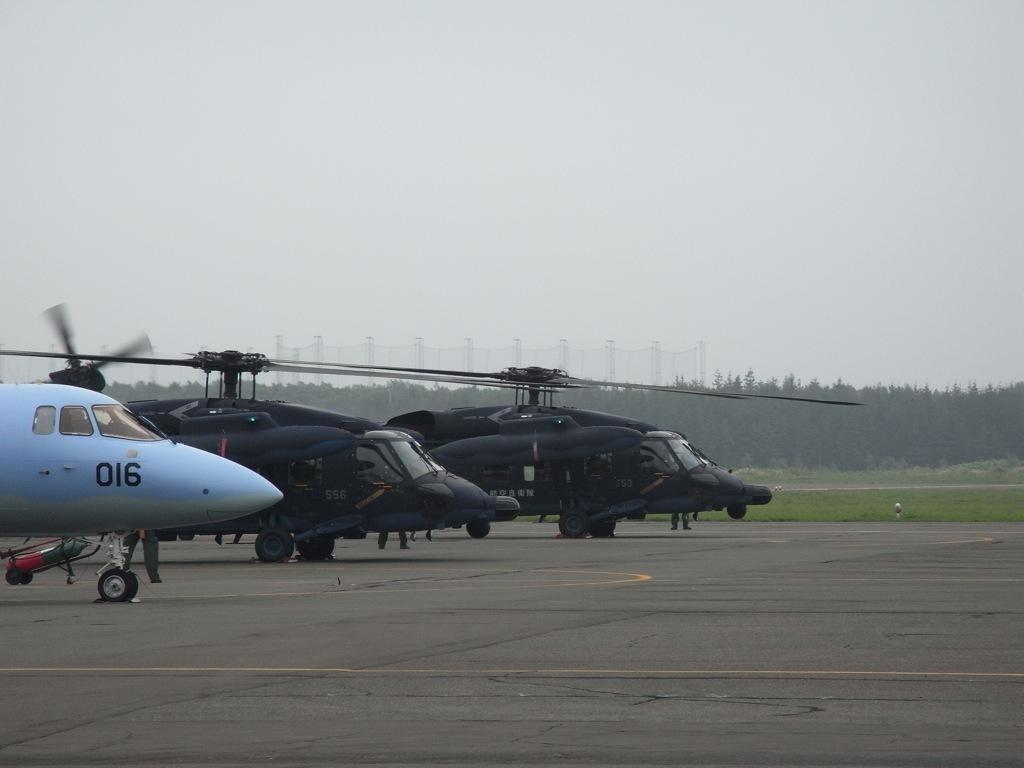What vehicles are on the road in the image? There are helicopters on the road in the image. Who or what else can be seen in the image? There are people in the image. What type of natural scenery is visible in the background of the image? There are trees in the background of the image. What is visible at the top of the image? The sky is visible at the top of the image. What toys are being used by the people in the image? There is no mention of toys in the image; it features helicopters on the road, people, trees, and the sky. 